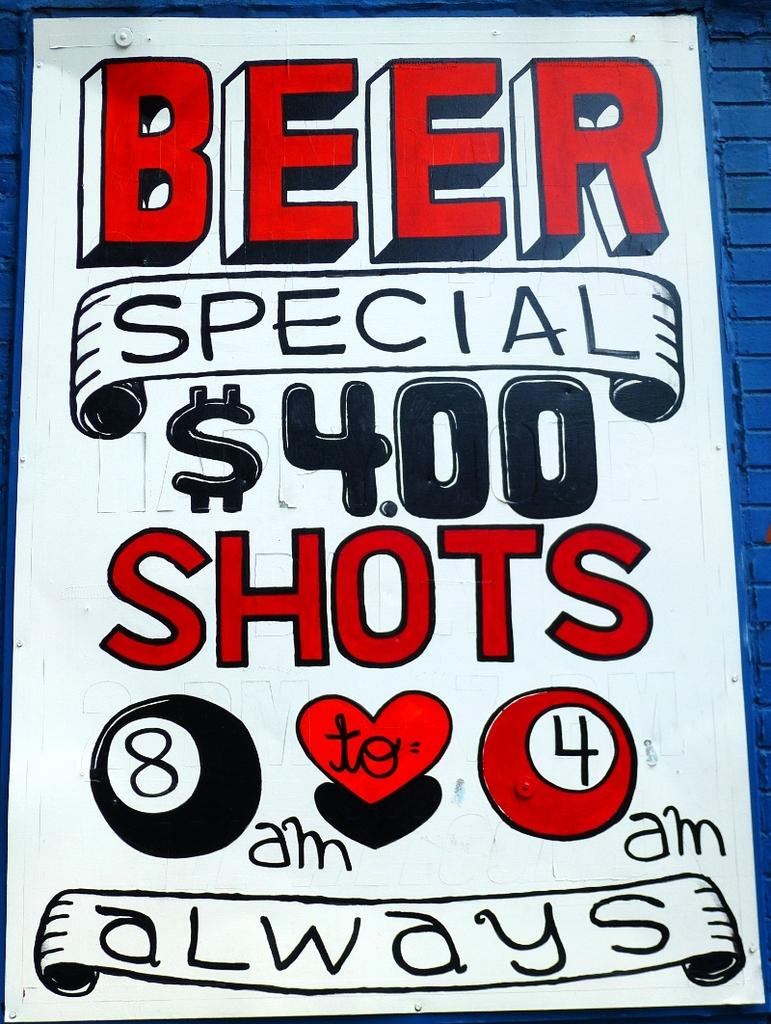<image>
Give a short and clear explanation of the subsequent image. The poster displays $4.00 shots from 8am - 4am on a daily basis. 